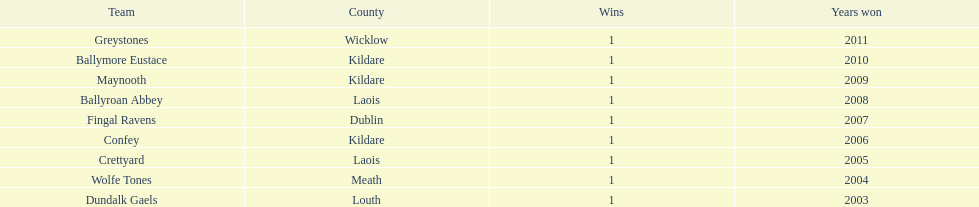What is the total of triumphs for each team? 1. 